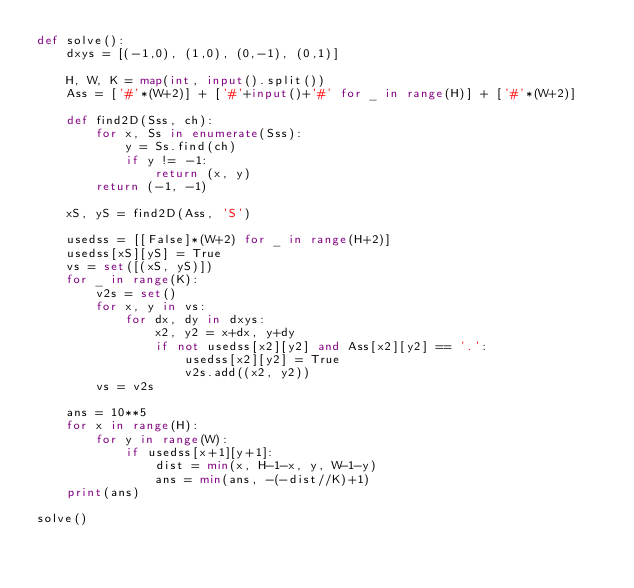Convert code to text. <code><loc_0><loc_0><loc_500><loc_500><_Python_>def solve():
    dxys = [(-1,0), (1,0), (0,-1), (0,1)]

    H, W, K = map(int, input().split())
    Ass = ['#'*(W+2)] + ['#'+input()+'#' for _ in range(H)] + ['#'*(W+2)]

    def find2D(Sss, ch):
        for x, Ss in enumerate(Sss):
            y = Ss.find(ch)
            if y != -1:
                return (x, y)
        return (-1, -1)

    xS, yS = find2D(Ass, 'S')

    usedss = [[False]*(W+2) for _ in range(H+2)]
    usedss[xS][yS] = True
    vs = set([(xS, yS)])
    for _ in range(K):
        v2s = set()
        for x, y in vs:
            for dx, dy in dxys:
                x2, y2 = x+dx, y+dy
                if not usedss[x2][y2] and Ass[x2][y2] == '.':
                    usedss[x2][y2] = True
                    v2s.add((x2, y2))
        vs = v2s

    ans = 10**5
    for x in range(H):
        for y in range(W):
            if usedss[x+1][y+1]:
                dist = min(x, H-1-x, y, W-1-y)
                ans = min(ans, -(-dist//K)+1)
    print(ans)

solve()
</code> 